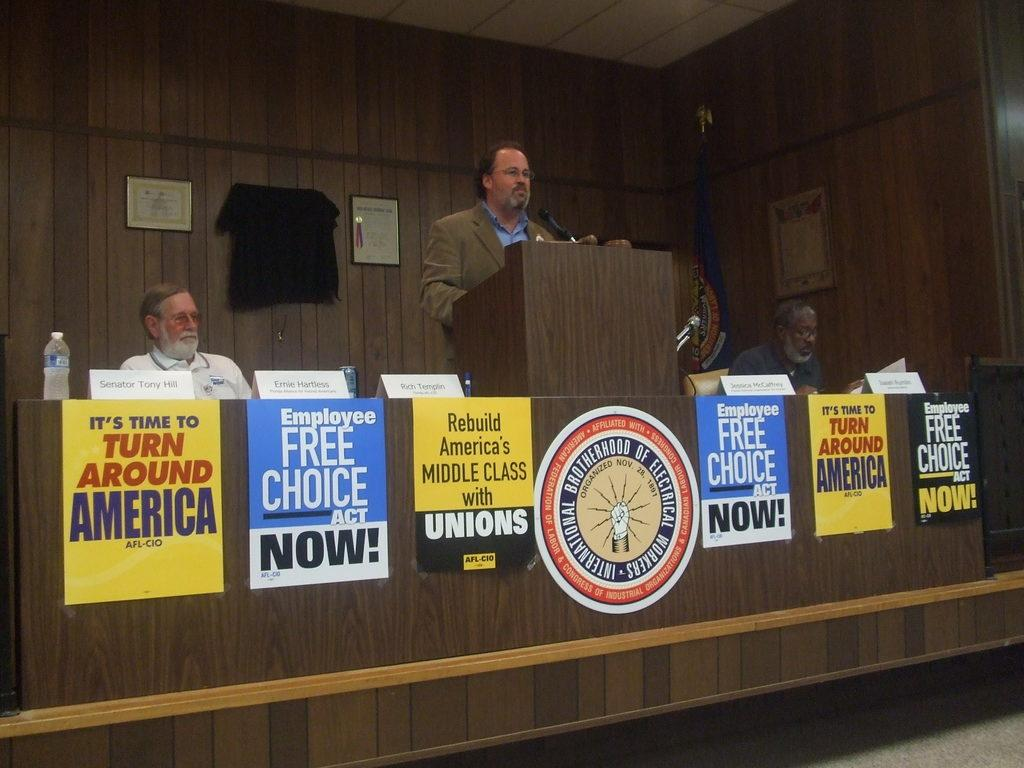<image>
Relay a brief, clear account of the picture shown. Man on the podium speaking of politics, with different signs saying Its Time to Turn Around America, Employee Free Choice Act Now, and Rebuild America's Class with Unions. 